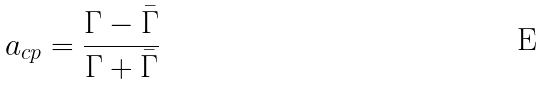Convert formula to latex. <formula><loc_0><loc_0><loc_500><loc_500>a _ { c p } = \frac { \Gamma - \bar { \Gamma } } { \Gamma + \bar { \Gamma } }</formula> 